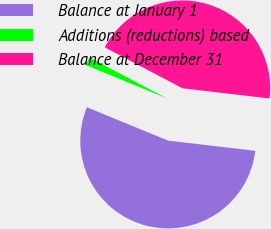<chart> <loc_0><loc_0><loc_500><loc_500><pie_chart><fcel>Balance at January 1<fcel>Additions (reductions) based<fcel>Balance at December 31<nl><fcel>54.35%<fcel>1.52%<fcel>44.13%<nl></chart> 